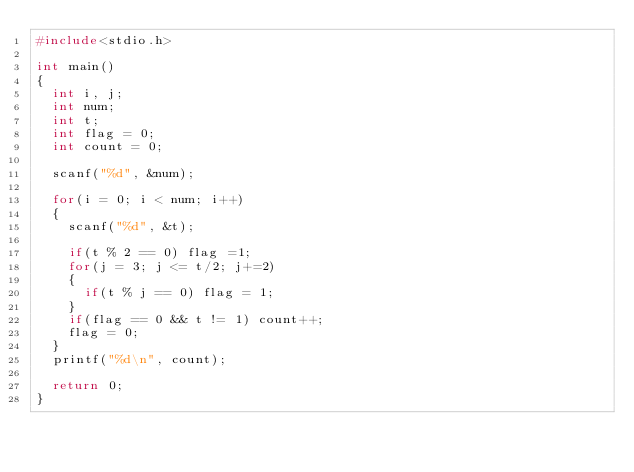<code> <loc_0><loc_0><loc_500><loc_500><_C_>#include<stdio.h>

int main()
{
	int i, j;
	int num;
	int t;
	int flag = 0;
	int count = 0;
	
	scanf("%d", &num);
	
	for(i = 0; i < num; i++)
	{
		scanf("%d", &t);
		
		if(t % 2 == 0) flag =1;
		for(j = 3; j <= t/2; j+=2)
		{
			if(t % j == 0) flag = 1;
		}
		if(flag == 0 && t != 1) count++;
		flag = 0;
	}
	printf("%d\n", count);
	
	return 0;
}</code> 